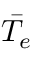<formula> <loc_0><loc_0><loc_500><loc_500>\bar { T _ { e } }</formula> 